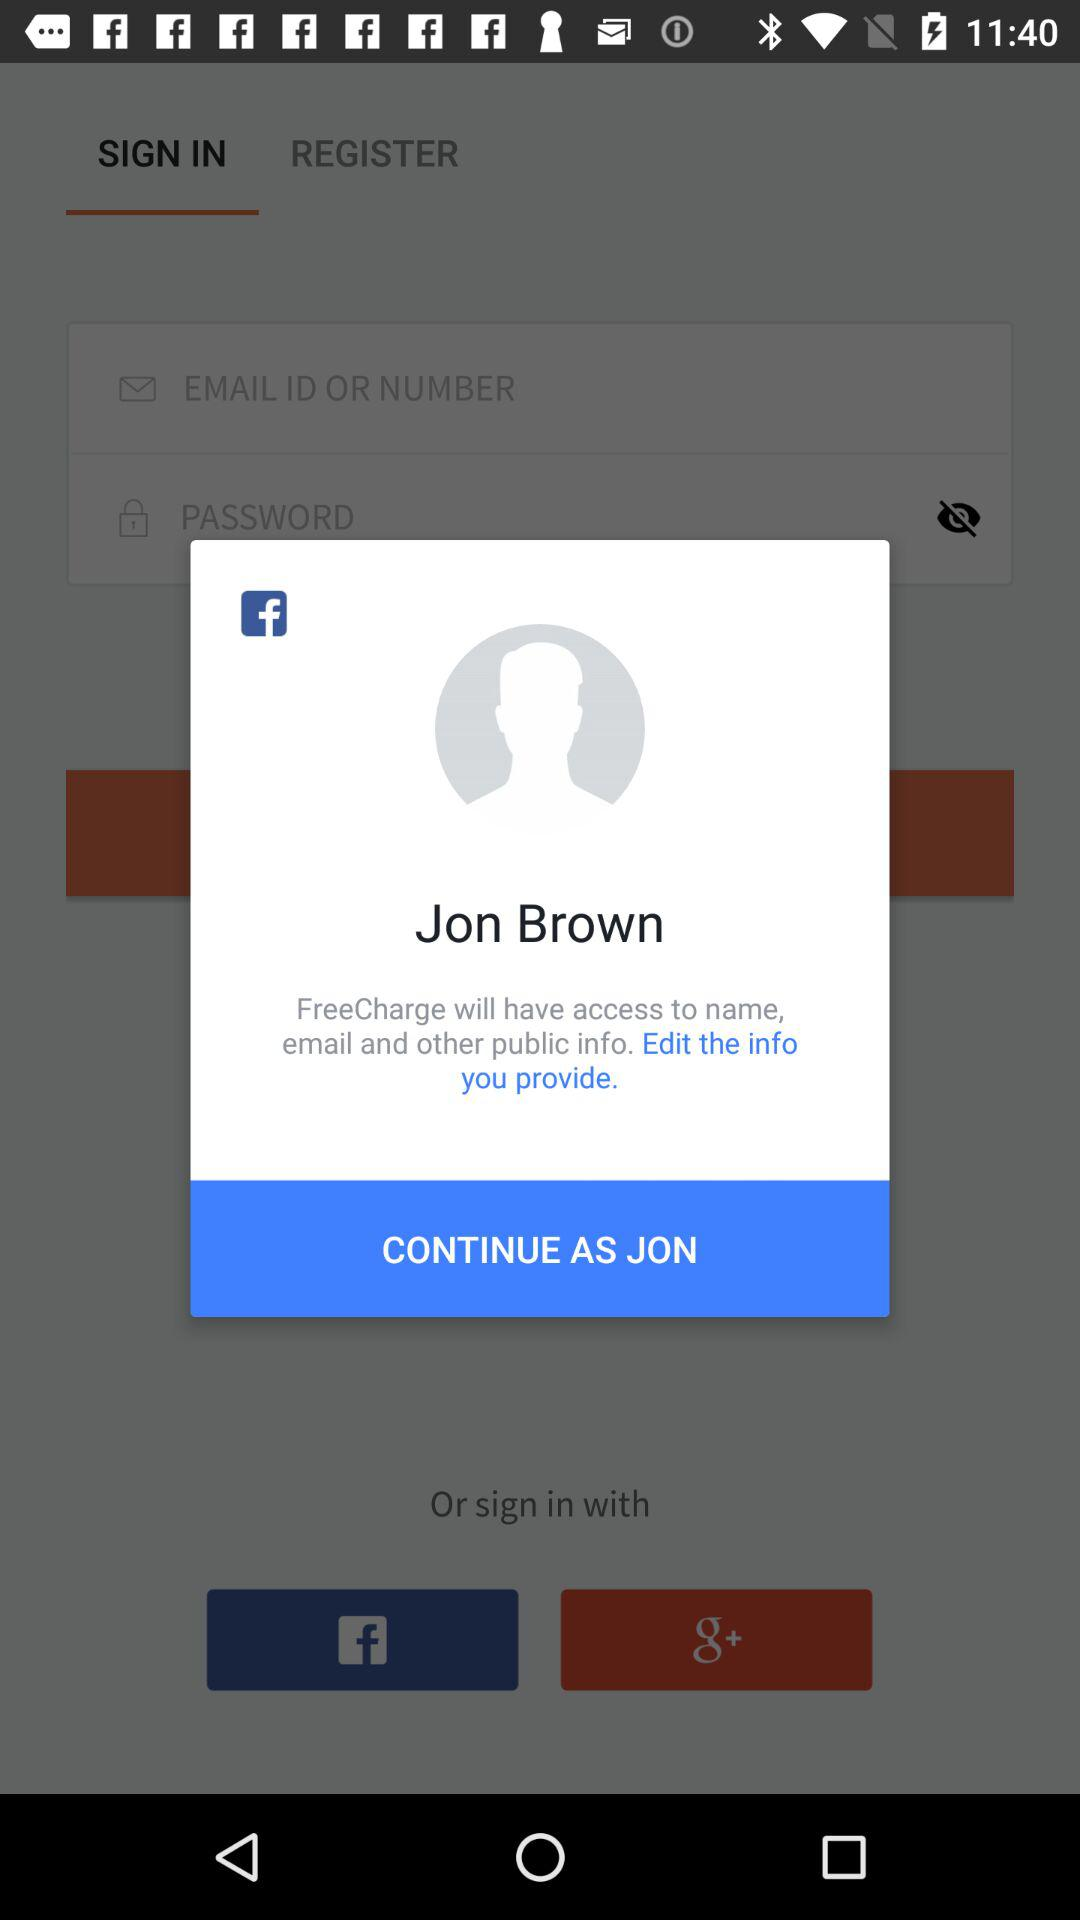What application is asking for permission? The application that is asking for permission is "FreeCharge". 